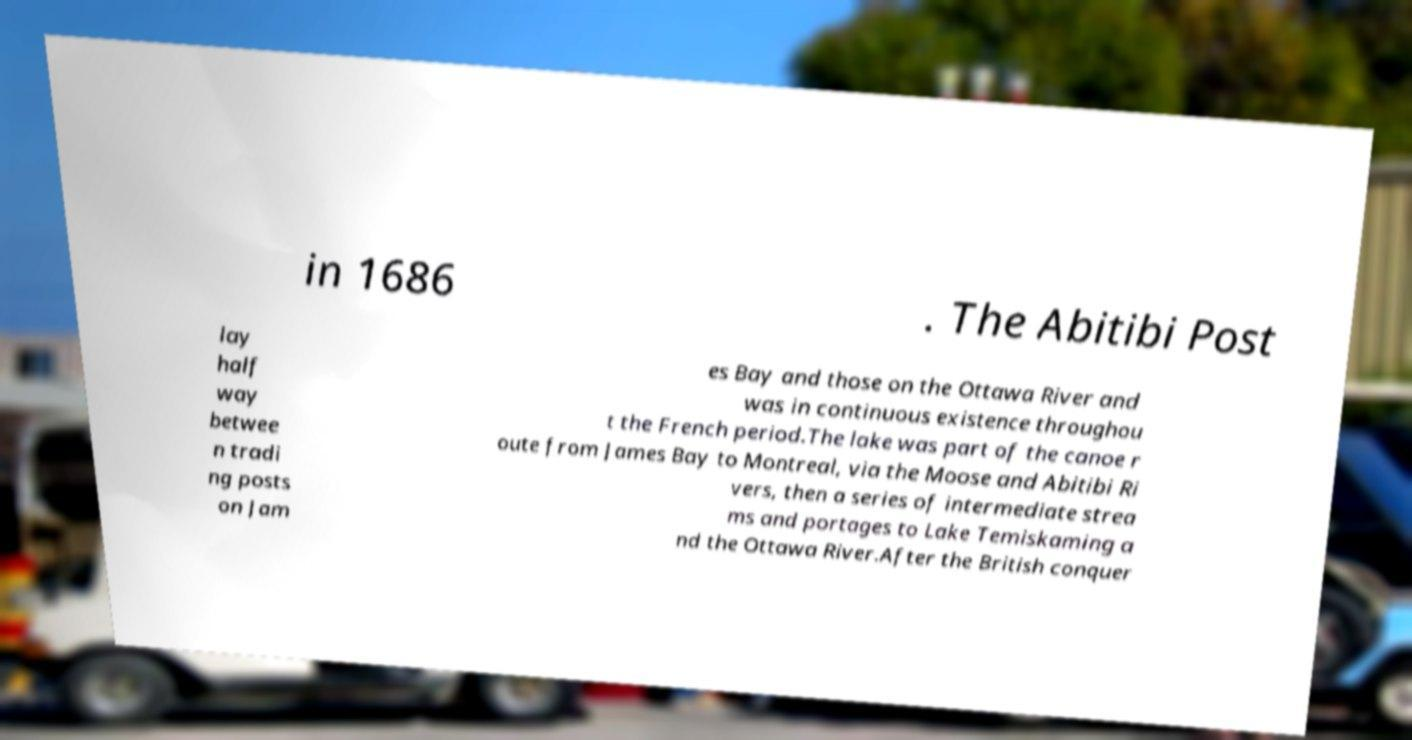Can you read and provide the text displayed in the image?This photo seems to have some interesting text. Can you extract and type it out for me? in 1686 . The Abitibi Post lay half way betwee n tradi ng posts on Jam es Bay and those on the Ottawa River and was in continuous existence throughou t the French period.The lake was part of the canoe r oute from James Bay to Montreal, via the Moose and Abitibi Ri vers, then a series of intermediate strea ms and portages to Lake Temiskaming a nd the Ottawa River.After the British conquer 